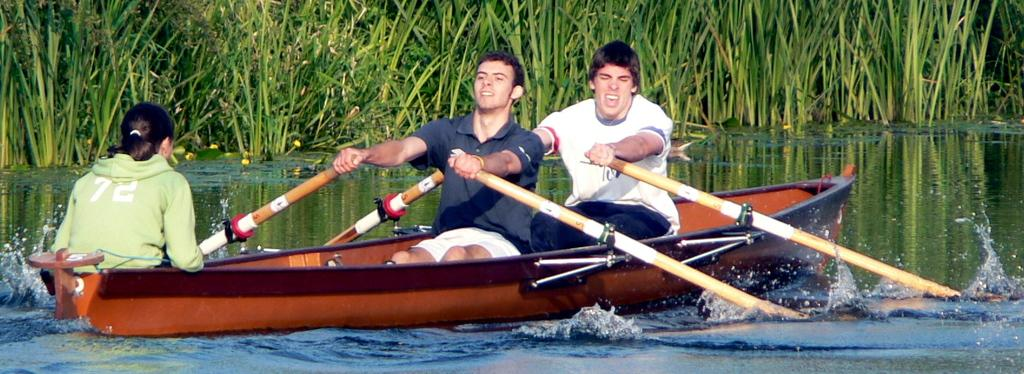How many people are in the image? There are three people in the image. What are the people doing in the image? The people are sitting in a boat. Where is the boat located in the image? The boat is on the water. What are the people holding in the image? The people are holding paddles. What can be seen in the background of the image? There are plants visible in the background of the image. What date is marked on the calendar in the image? There is no calendar present in the image. Can you describe the cherry that is being eaten by one of the people in the image? There is no cherry present in the image; the people are holding paddles and sitting in a boat on the water. 